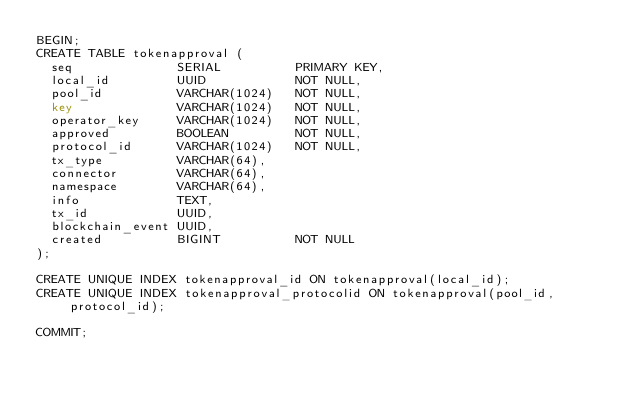<code> <loc_0><loc_0><loc_500><loc_500><_SQL_>BEGIN;
CREATE TABLE tokenapproval (
  seq              SERIAL          PRIMARY KEY,
  local_id         UUID            NOT NULL,
  pool_id          VARCHAR(1024)   NOT NULL,
  key              VARCHAR(1024)   NOT NULL,
  operator_key     VARCHAR(1024)   NOT NULL,
  approved         BOOLEAN         NOT NULL,
  protocol_id      VARCHAR(1024)   NOT NULL,
  tx_type          VARCHAR(64),
  connector        VARCHAR(64),
  namespace        VARCHAR(64),
  info             TEXT,
  tx_id            UUID,
  blockchain_event UUID,
  created          BIGINT          NOT NULL
);

CREATE UNIQUE INDEX tokenapproval_id ON tokenapproval(local_id);
CREATE UNIQUE INDEX tokenapproval_protocolid ON tokenapproval(pool_id, protocol_id);

COMMIT;
</code> 